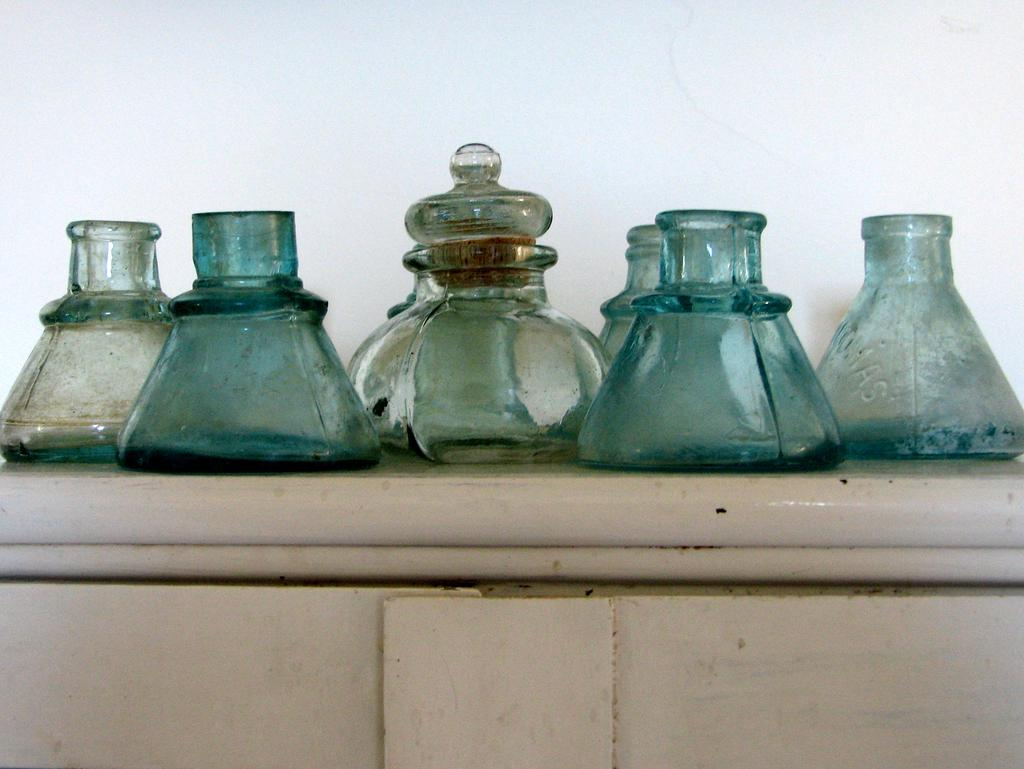What type of containers are visible in the image? There are glass bottles in the image. Where are the glass bottles located? The glass bottles are placed on a table. What type of whip is being used to clean the dust off the glass bottles in the image? There is no whip or dust present in the image; it only shows glass bottles placed on a table. 